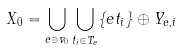Convert formula to latex. <formula><loc_0><loc_0><loc_500><loc_500>X _ { 0 } = \bigcup _ { e \ni v _ { 0 } } \bigcup _ { t _ { i } \in T _ { e } } \{ e t _ { i } \} \oplus Y _ { e , i }</formula> 